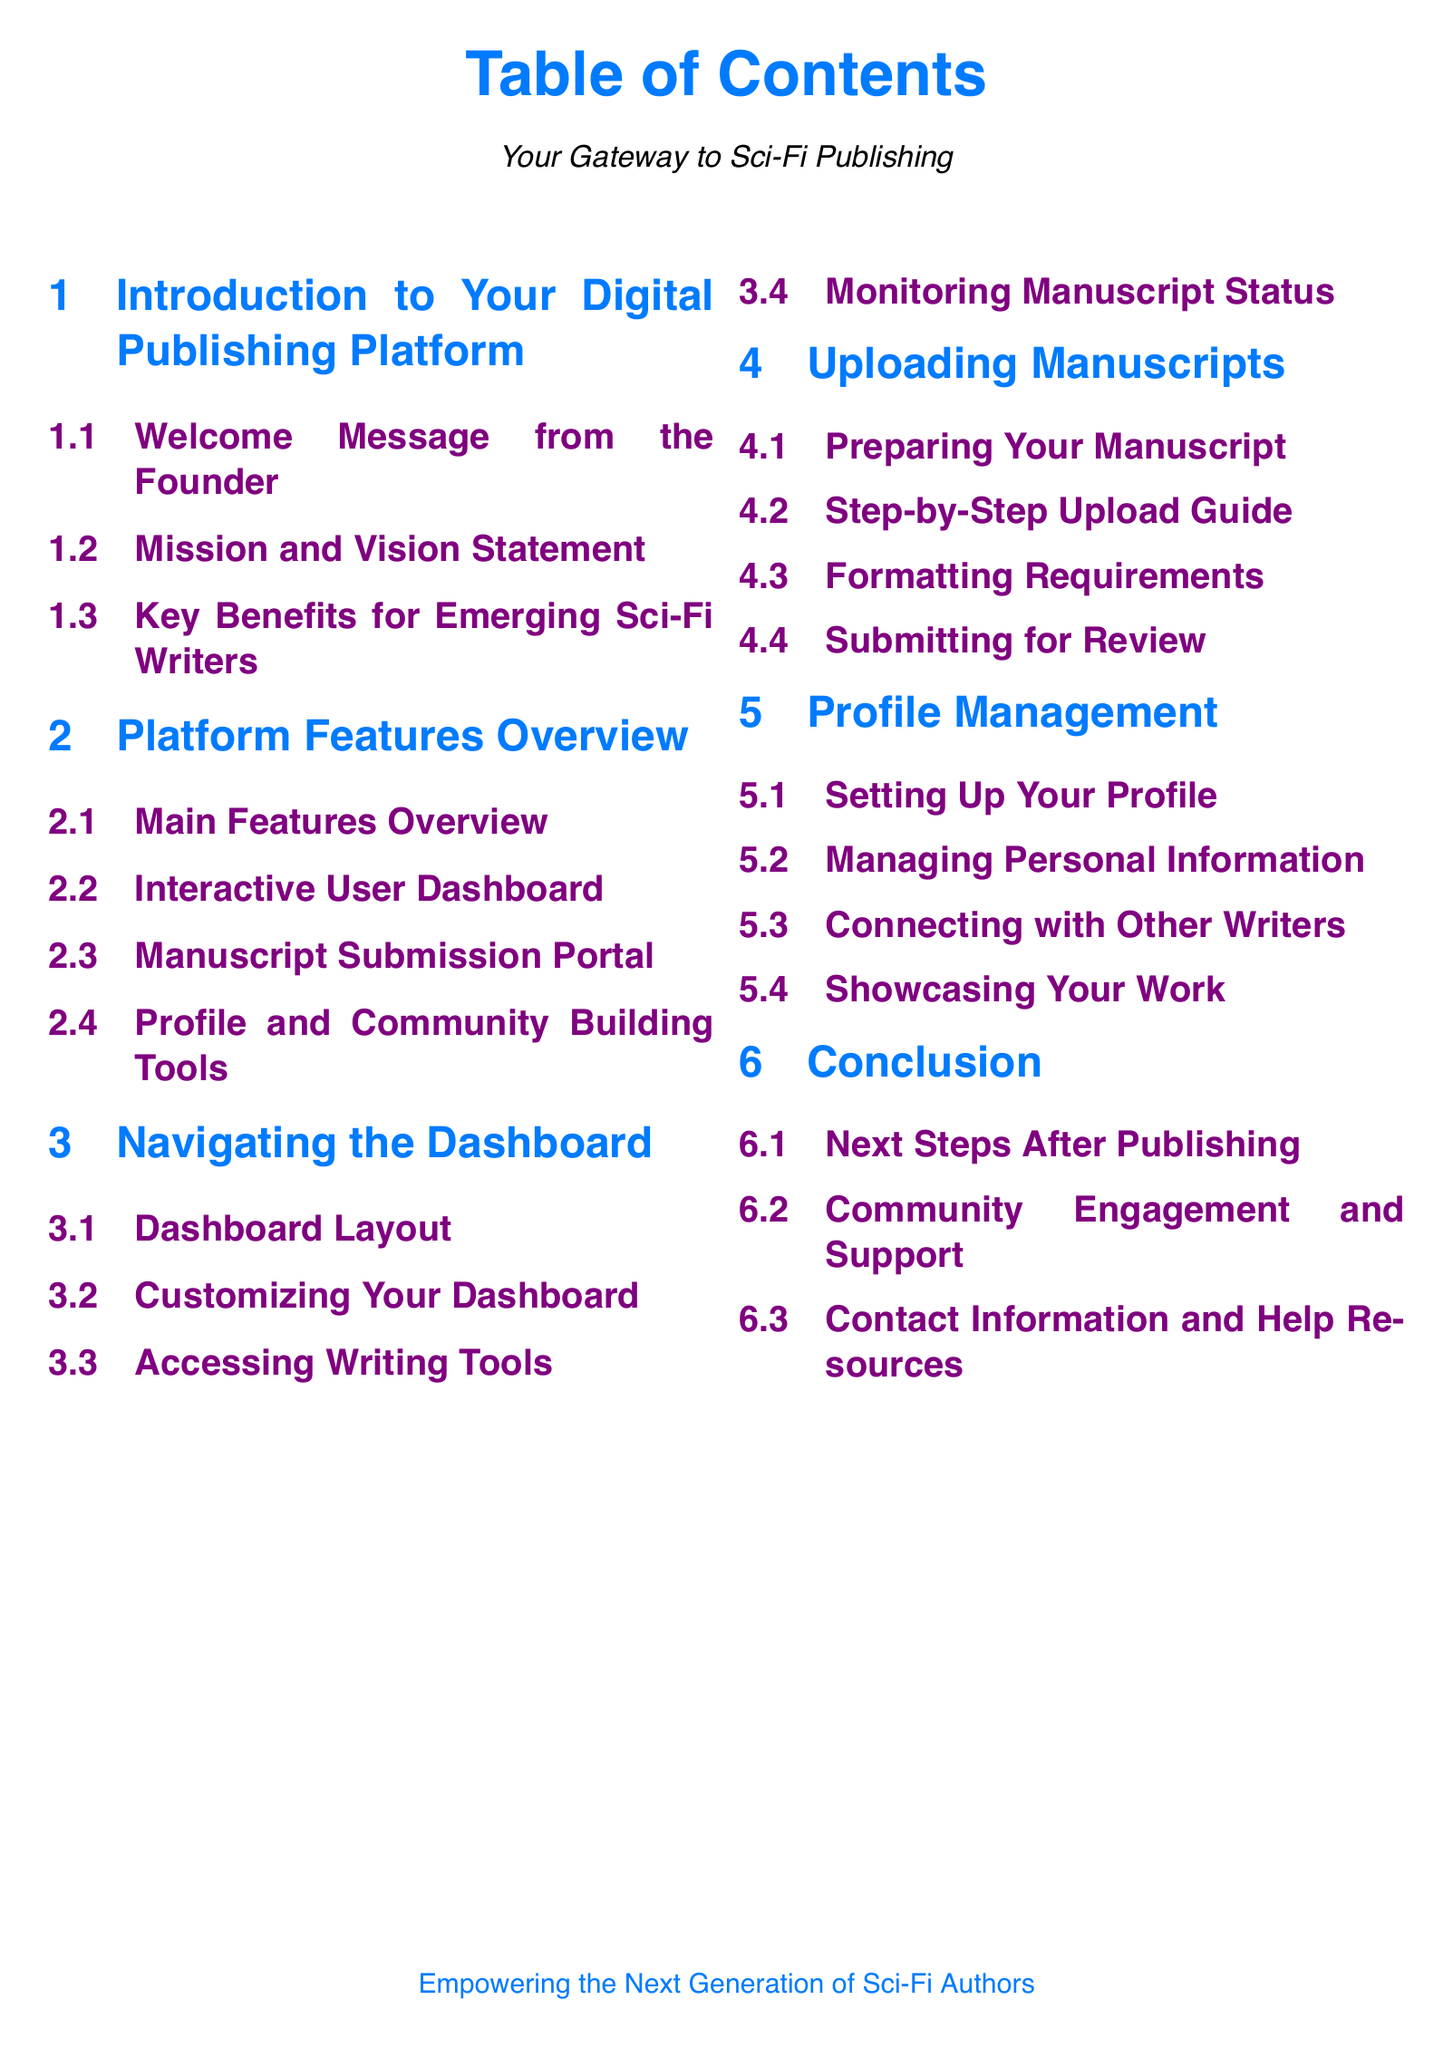What is the title of the document? The title of the document is displayed prominently at the top of the Table of Contents page.
Answer: Table of Contents How many sections are in the document? The document contains six main sections as indicated in the Table of Contents.
Answer: 6 What color is used for section titles? The color used for section titles is specified in the document formatting.
Answer: Sci-fi blue What is one of the key benefits mentioned for emerging sci-fi writers? Key benefits for emerging sci-fi writers are detailed in the section titled "Key Benefits for Emerging Sci-Fi Writers."
Answer: Support What is the first subsection under Profile Management? The first subsection listed under Profile Management provides insight into setting up user profiles.
Answer: Setting Up Your Profile Which section contains the guide for uploading manuscripts? The section that contains the guide specifically for uploading manuscripts is indicated clearly in the Table of Contents.
Answer: Uploading Manuscripts What is the last subsection in the Conclusion section? The last subsection in the Conclusion section summarizes resources available for users.
Answer: Contact Information and Help Resources How can writers showcase their work? The process for showcasing work is addressed in the Profile Management section.
Answer: Showcasing Your Work What is one of the features of the Interactive User Dashboard? Features of the Interactive User Dashboard are summarized in its dedicated subsection.
Answer: Customizing Your Dashboard 